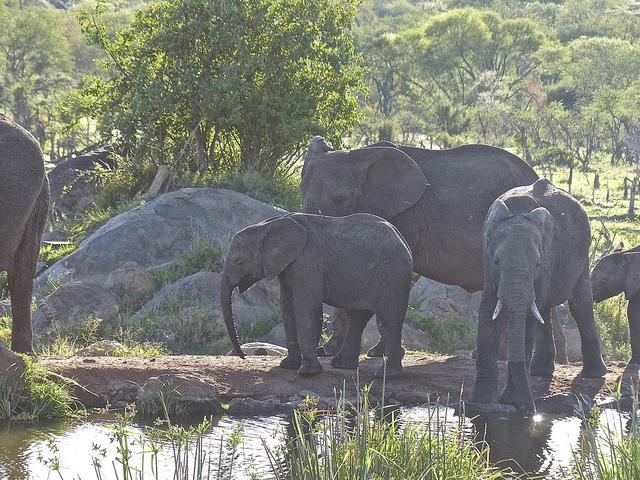Why are there several elephants gathered at this place?
Keep it brief. Water. Are tusks visible?
Answer briefly. Yes. Which elephant is the youngest?
Give a very brief answer. Middle one. Is this a colorful picture?
Short answer required. Yes. 